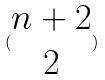<formula> <loc_0><loc_0><loc_500><loc_500>( \begin{matrix} n + 2 \\ 2 \end{matrix} )</formula> 